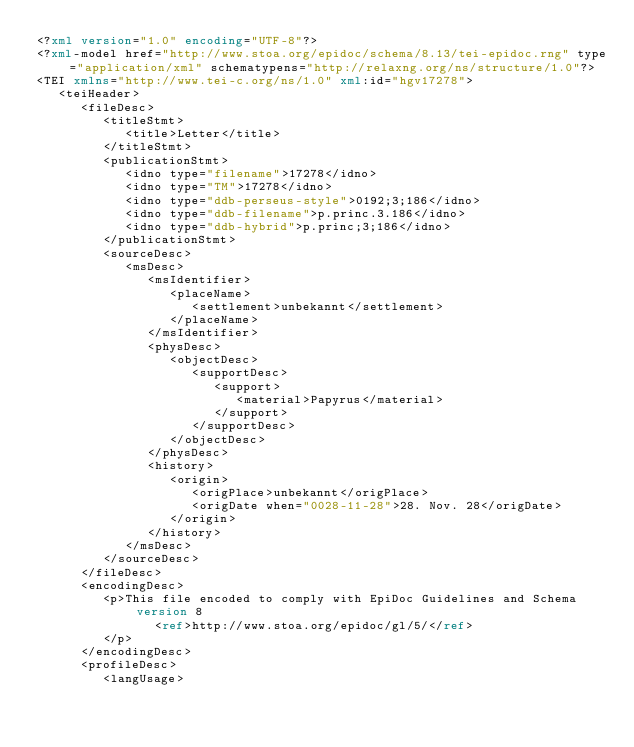Convert code to text. <code><loc_0><loc_0><loc_500><loc_500><_XML_><?xml version="1.0" encoding="UTF-8"?>
<?xml-model href="http://www.stoa.org/epidoc/schema/8.13/tei-epidoc.rng" type="application/xml" schematypens="http://relaxng.org/ns/structure/1.0"?>
<TEI xmlns="http://www.tei-c.org/ns/1.0" xml:id="hgv17278">
   <teiHeader>
      <fileDesc>
         <titleStmt>
            <title>Letter</title>
         </titleStmt>
         <publicationStmt>
            <idno type="filename">17278</idno>
            <idno type="TM">17278</idno>
            <idno type="ddb-perseus-style">0192;3;186</idno>
            <idno type="ddb-filename">p.princ.3.186</idno>
            <idno type="ddb-hybrid">p.princ;3;186</idno>
         </publicationStmt>
         <sourceDesc>
            <msDesc>
               <msIdentifier>
                  <placeName>
                     <settlement>unbekannt</settlement>
                  </placeName>
               </msIdentifier>
               <physDesc>
                  <objectDesc>
                     <supportDesc>
                        <support>
                           <material>Papyrus</material>
                        </support>
                     </supportDesc>
                  </objectDesc>
               </physDesc>
               <history>
                  <origin>
                     <origPlace>unbekannt</origPlace>
                     <origDate when="0028-11-28">28. Nov. 28</origDate>
                  </origin>
               </history>
            </msDesc>
         </sourceDesc>
      </fileDesc>
      <encodingDesc>
         <p>This file encoded to comply with EpiDoc Guidelines and Schema version 8
                <ref>http://www.stoa.org/epidoc/gl/5/</ref>
         </p>
      </encodingDesc>
      <profileDesc>
         <langUsage></code> 